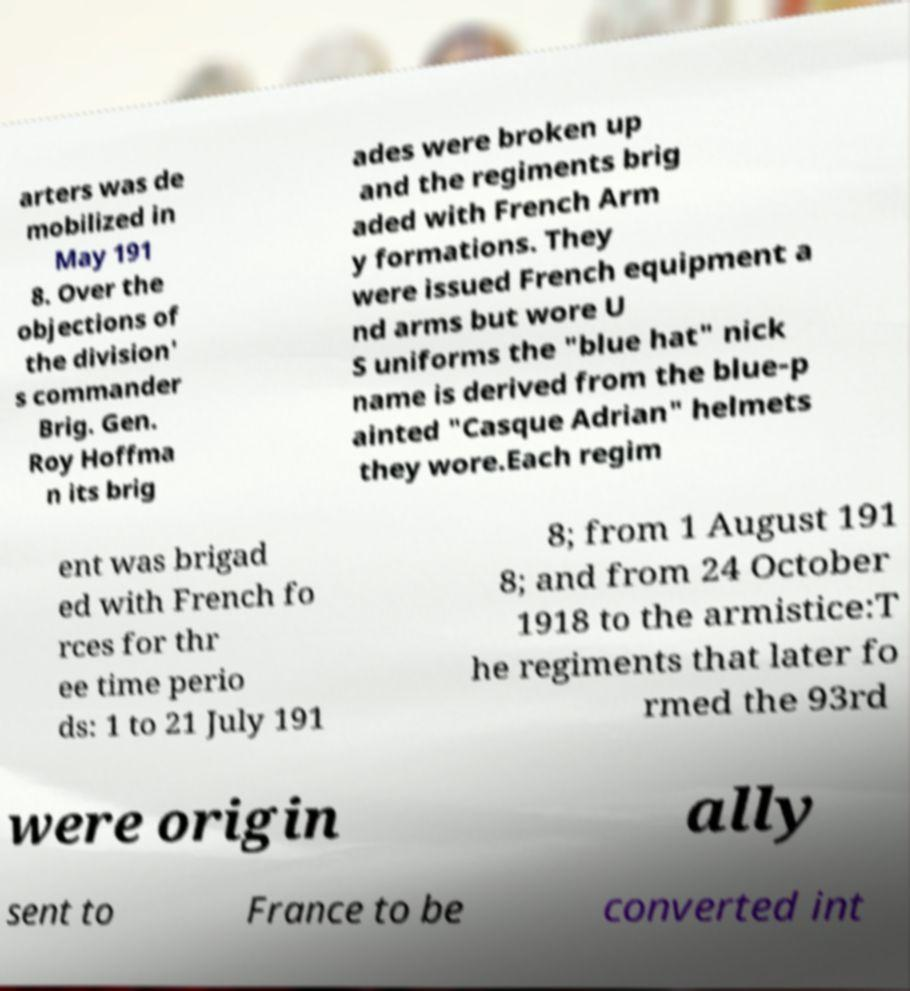What messages or text are displayed in this image? I need them in a readable, typed format. arters was de mobilized in May 191 8. Over the objections of the division' s commander Brig. Gen. Roy Hoffma n its brig ades were broken up and the regiments brig aded with French Arm y formations. They were issued French equipment a nd arms but wore U S uniforms the "blue hat" nick name is derived from the blue-p ainted "Casque Adrian" helmets they wore.Each regim ent was brigad ed with French fo rces for thr ee time perio ds: 1 to 21 July 191 8; from 1 August 191 8; and from 24 October 1918 to the armistice:T he regiments that later fo rmed the 93rd were origin ally sent to France to be converted int 